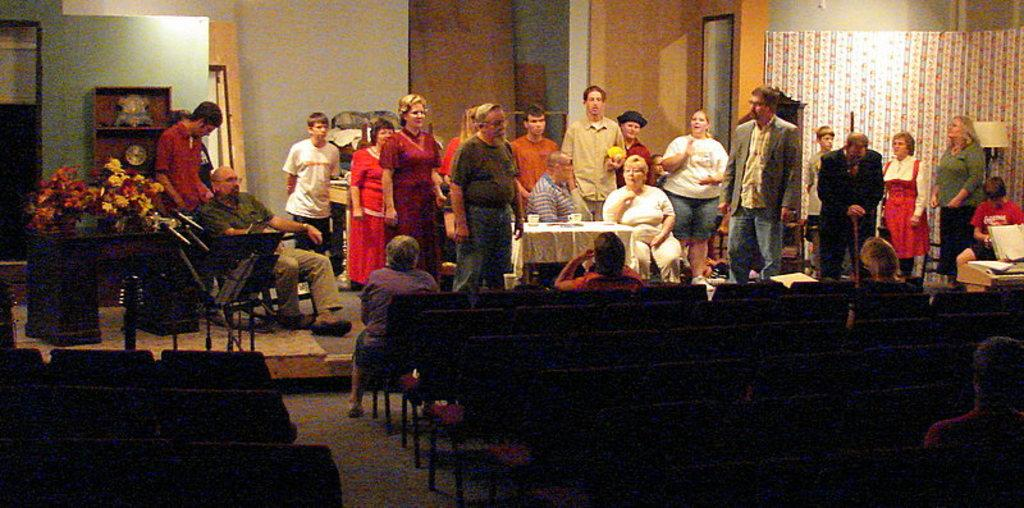What type of structure can be seen in the image? There is a wall in the image. What type of window treatment is present in the image? There are curtains in the image. What type of lighting is present in the image? There is a lamp in the image. What type of furniture is present in the image? There are chairs and tables in the image. What type of decoration is present in the image? There are flowers in the image. Who or what is present in the image? There is a group of people in the image. What type of reward is being given to the person with the most expert elbow in the image? There is no mention of a reward or an expert elbow in the image. 